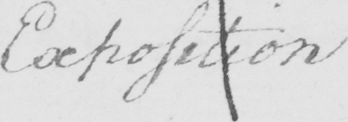Can you read and transcribe this handwriting? Exposition 